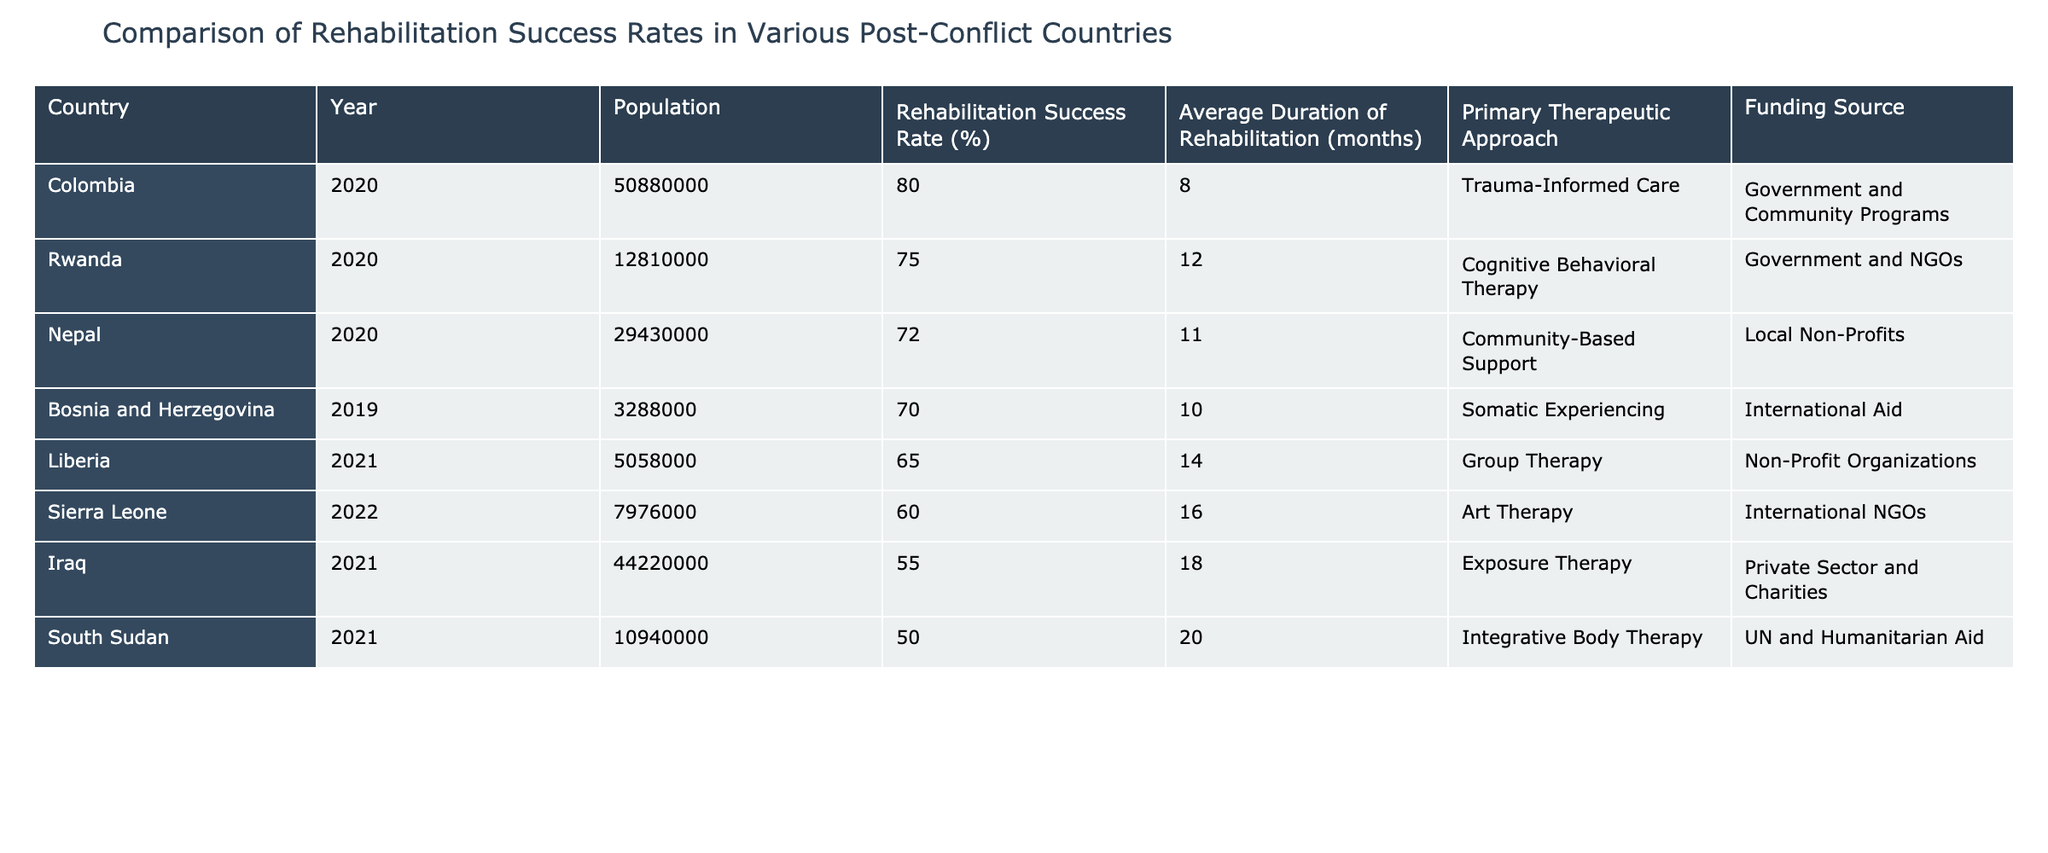What is the rehabilitation success rate in Colombia? The table shows that Colombia has a rehabilitation success rate of 80% listed in the column for "Rehabilitation Success Rate (%)".
Answer: 80% Which country has the lowest rehabilitation success rate? By examining the "Rehabilitation Success Rate (%)" column, Iraq is listed with the lowest success rate of 55%.
Answer: Iraq What is the average duration of rehabilitation across all countries in the table (in months)? To find the average, we sum the durations: 12 + 10 + 14 + 8 + 16 + 18 + 20 + 11 = 119. There are 8 countries, so the average is 119/8 = 14.875, which we can round to 15 months.
Answer: 15 months Is the primary therapeutic approach in Liberia 'Group Therapy'? Looking at the "Primary Therapeutic Approach" column, Liberia's approach is indeed listed as 'Group Therapy'.
Answer: Yes How many countries have a rehabilitation success rate of 70% or higher? We check the "Rehabilitation Success Rate (%)" column for values 70% or above: Rwanda (75%), Colombia (80%), and Nepal (72%) total three countries.
Answer: 3 What is the funding source for rehabilitation in South Sudan? The table indicates that South Sudan's funding source is 'UN and Humanitarian Aid' as listed in the "Funding Source" column.
Answer: UN and Humanitarian Aid Which country has the longest average duration of rehabilitation, and what is that duration? We review the "Average Duration of Rehabilitation (months)" column; South Sudan has the longest duration of 20 months.
Answer: 20 months If we compare Nepal and Liberia, which country has a higher rehabilitation success rate and by how much? Nepal has a success rate of 72% while Liberia has 65%. The difference is 72 - 65 = 7%, indicating Nepal's rate is higher by 7%.
Answer: 7% What therapeutic approach is used in Iraq? The table specifies that Iraq's primary therapeutic approach is 'Exposure Therapy'.
Answer: Exposure Therapy 